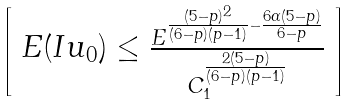Convert formula to latex. <formula><loc_0><loc_0><loc_500><loc_500>\left [ \begin{array} { l } E ( I u _ { 0 } ) \leq \frac { E ^ { \frac { ( 5 - p ) ^ { 2 } } { ( 6 - p ) ( p - 1 ) } - \frac { 6 \alpha ( 5 - p ) } { 6 - p } } } { C _ { 1 } ^ { \frac { 2 ( 5 - p ) } { ( 6 - p ) ( p - 1 ) } } } \end{array} \right ]</formula> 